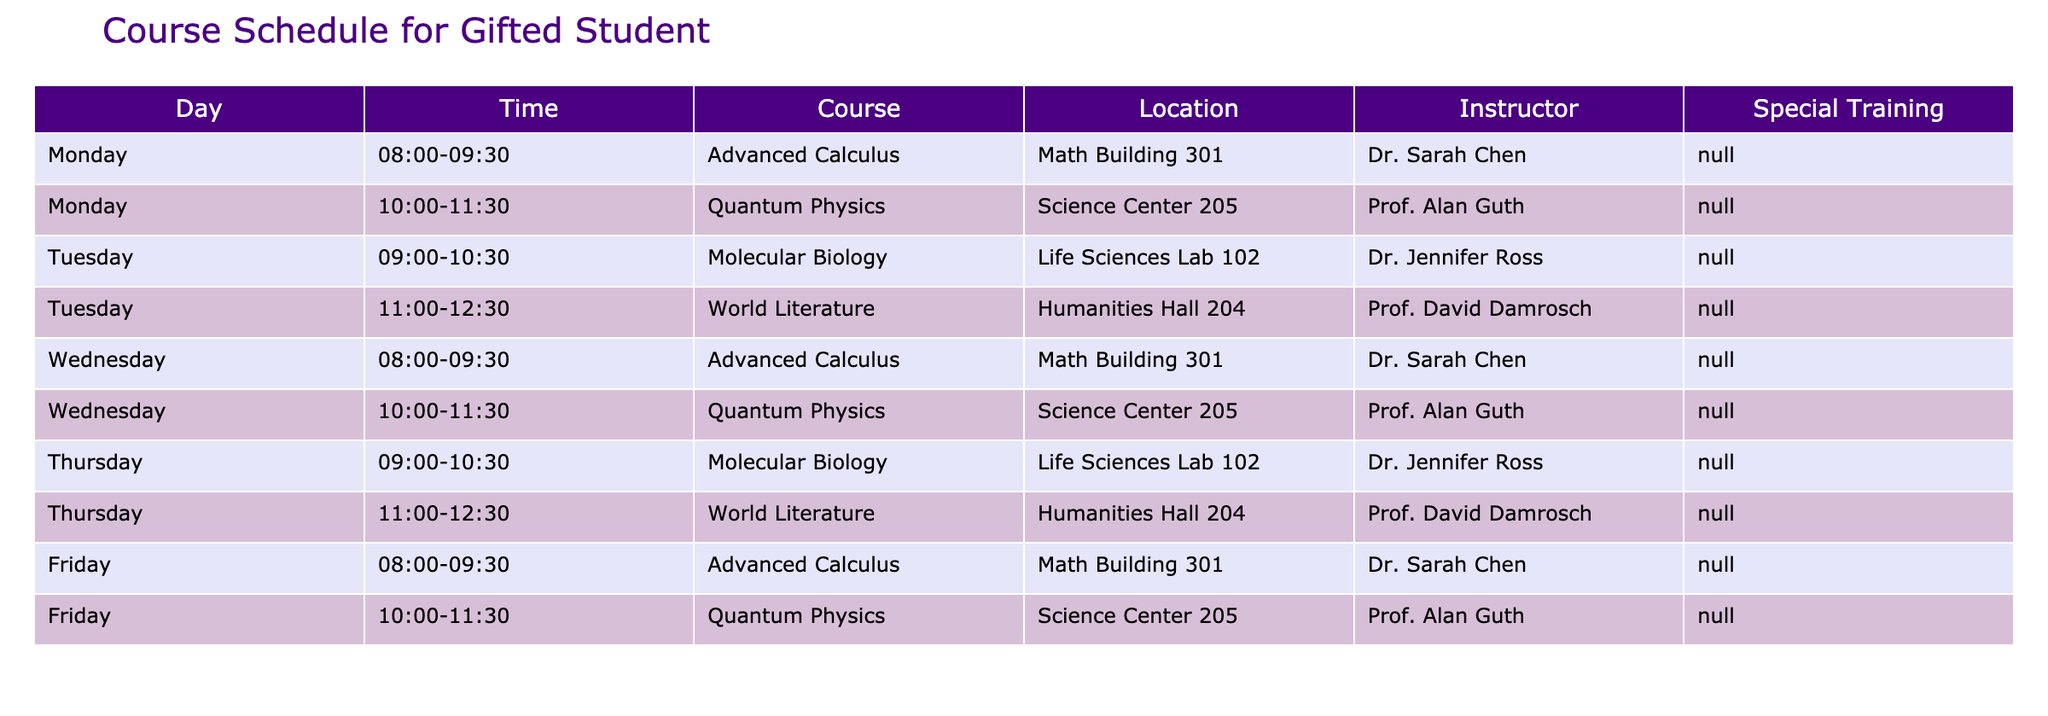What courses are offered on Mondays? According to the table, on Monday, the courses listed are Advanced Calculus from 08:00 to 09:30 and Quantum Physics from 10:00 to 11:30.
Answer: Advanced Calculus, Quantum Physics Which instructor teaches Molecular Biology? From the table, it is indicated that Molecular Biology is taught by Dr. Jennifer Ross on both Tuesday and Thursday at 09:00 to 10:30.
Answer: Dr. Jennifer Ross How many courses are scheduled in total? The table lists five unique courses, which are Advanced Calculus, Quantum Physics, Molecular Biology, and World Literature. Each course is repeated across different days. Therefore, there are 10 sessions, but only 4 unique courses.
Answer: 10 sessions Is World Literature offered on both Tuesday and Thursday? Yes, the table shows that World Literature is scheduled on Tuesday from 11:00 to 12:30 and also on Thursday from 11:00 to 12:30.
Answer: Yes How many unique days have Advanced Calculus classes? The table lists Advanced Calculus on Monday, Wednesday, and Friday. This indicates that Advanced Calculus classes occur three times a week, spread across three unique days.
Answer: 3 days What is the time difference between the start of the first course on Monday and the start of the first course on Tuesday? The first course on Monday starts at 08:00, while the first course on Tuesday begins at 09:00. The time difference is then one hour.
Answer: 1 hour Which course has the latest start time on Fridays? On Friday, the latest start time is for Quantum Physics, which begins at 10:00.
Answer: Quantum Physics Are there any classes scheduled during lunchtime? Based on the schedule, there are no courses scheduled between 12:30 and 13:00, indicating no overlap with typical lunch hours.
Answer: No What percentage of the courses are taught by Prof. Alan Guth? Prof. Alan Guth teaches Quantum Physics, which appears three times a week (Monday, Wednesday, and Friday). Since there are a total of 10 courses, the calculation would be (3/10) * 100% = 30%.
Answer: 30% 